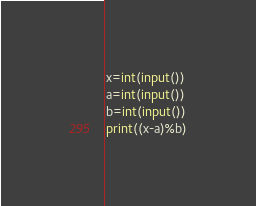<code> <loc_0><loc_0><loc_500><loc_500><_Python_>x=int(input())
a=int(input())
b=int(input())
print((x-a)%b)</code> 